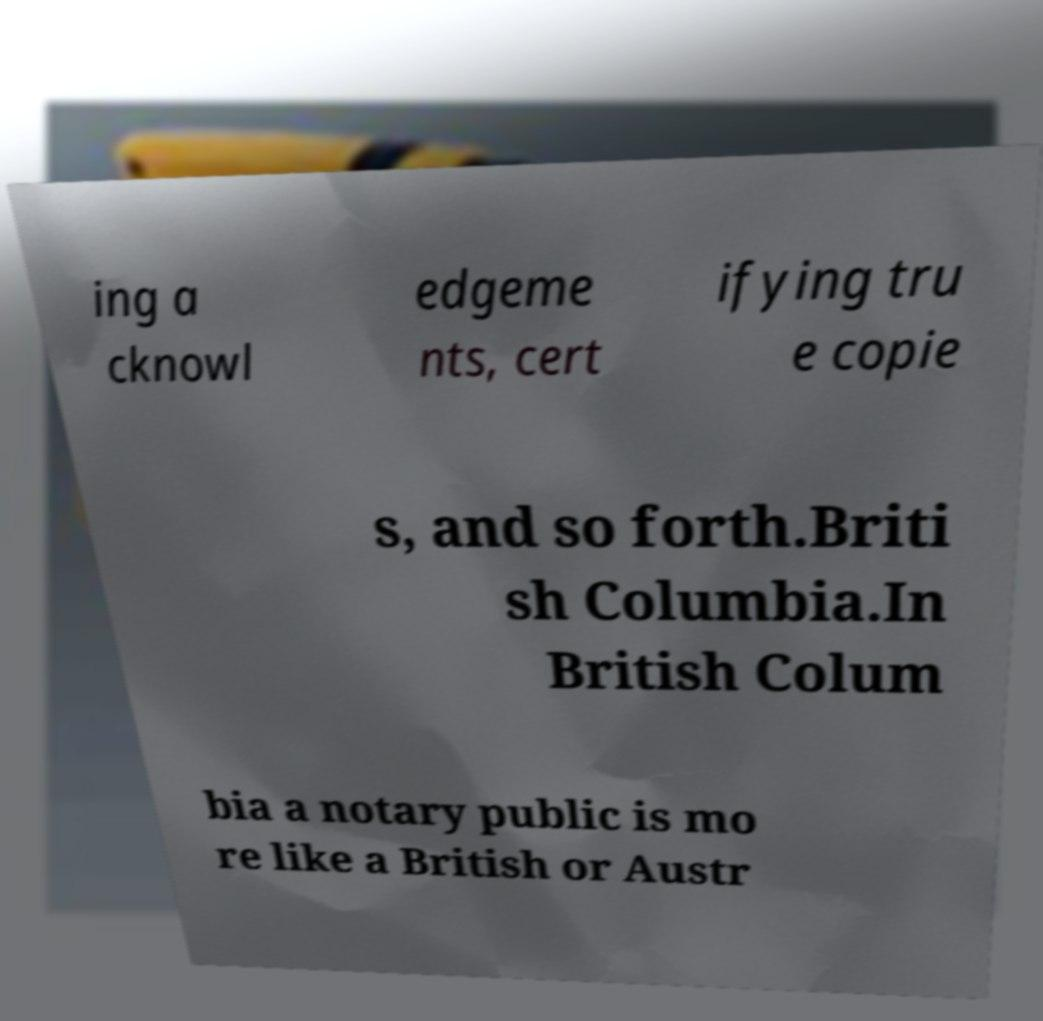Could you extract and type out the text from this image? ing a cknowl edgeme nts, cert ifying tru e copie s, and so forth.Briti sh Columbia.In British Colum bia a notary public is mo re like a British or Austr 